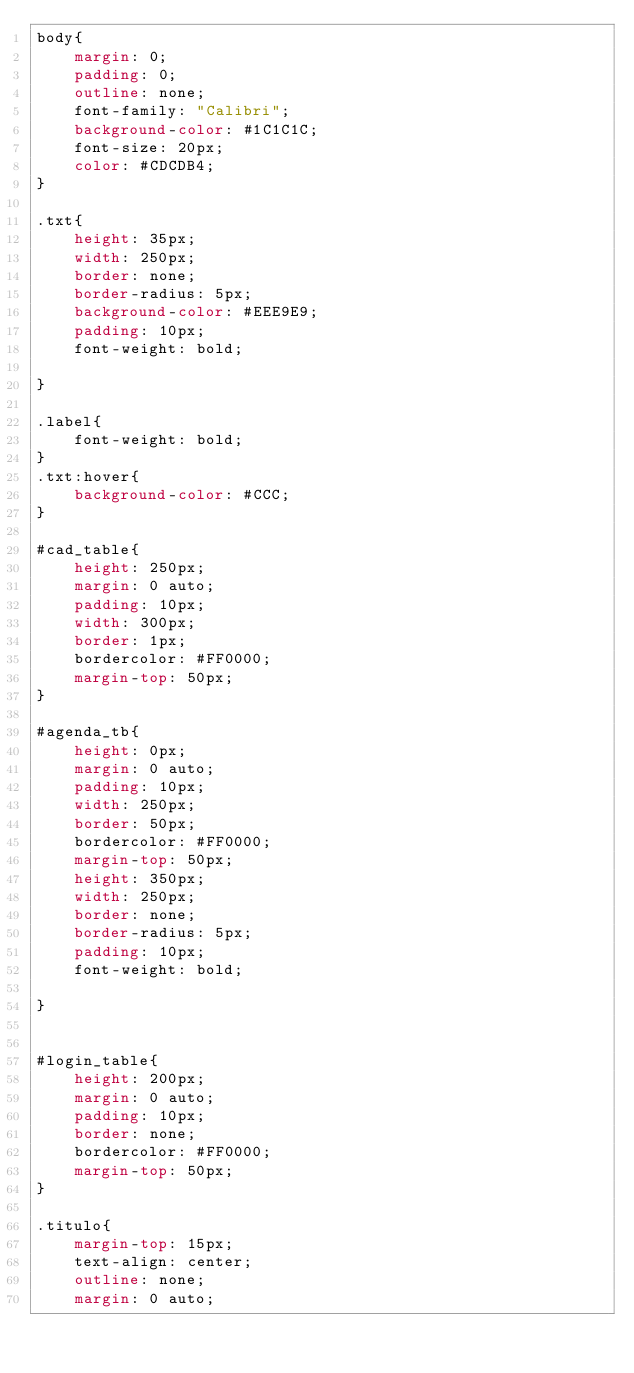<code> <loc_0><loc_0><loc_500><loc_500><_CSS_>body{
    margin: 0;
    padding: 0;
    outline: none;
    font-family: "Calibri";
    background-color: #1C1C1C;
    font-size: 20px;
    color: #CDCDB4;
}

.txt{
    height: 35px;
    width: 250px;
    border: none;
    border-radius: 5px;
    background-color: #EEE9E9;
    padding: 10px;
    font-weight: bold;
    
}

.label{
    font-weight: bold;
}
.txt:hover{
    background-color: #CCC; 
}

#cad_table{
    height: 250px;
    margin: 0 auto;
    padding: 10px;
    width: 300px; 
    border: 1px;
    bordercolor: #FF0000;
    margin-top: 50px;
}

#agenda_tb{
    height: 0px;
    margin: 0 auto;
    padding: 10px;
    width: 250px; 
    border: 50px;
    bordercolor: #FF0000;
    margin-top: 50px;
    height: 350px;
    width: 250px;
    border: none;
    border-radius: 5px;
    padding: 10px;
    font-weight: bold;
    
}


#login_table{
    height: 200px;
    margin: 0 auto;
    padding: 10px;
    border: none;
    bordercolor: #FF0000;
    margin-top: 50px;
}

.titulo{
    margin-top: 15px;
    text-align: center;
    outline: none;
    margin: 0 auto;</code> 